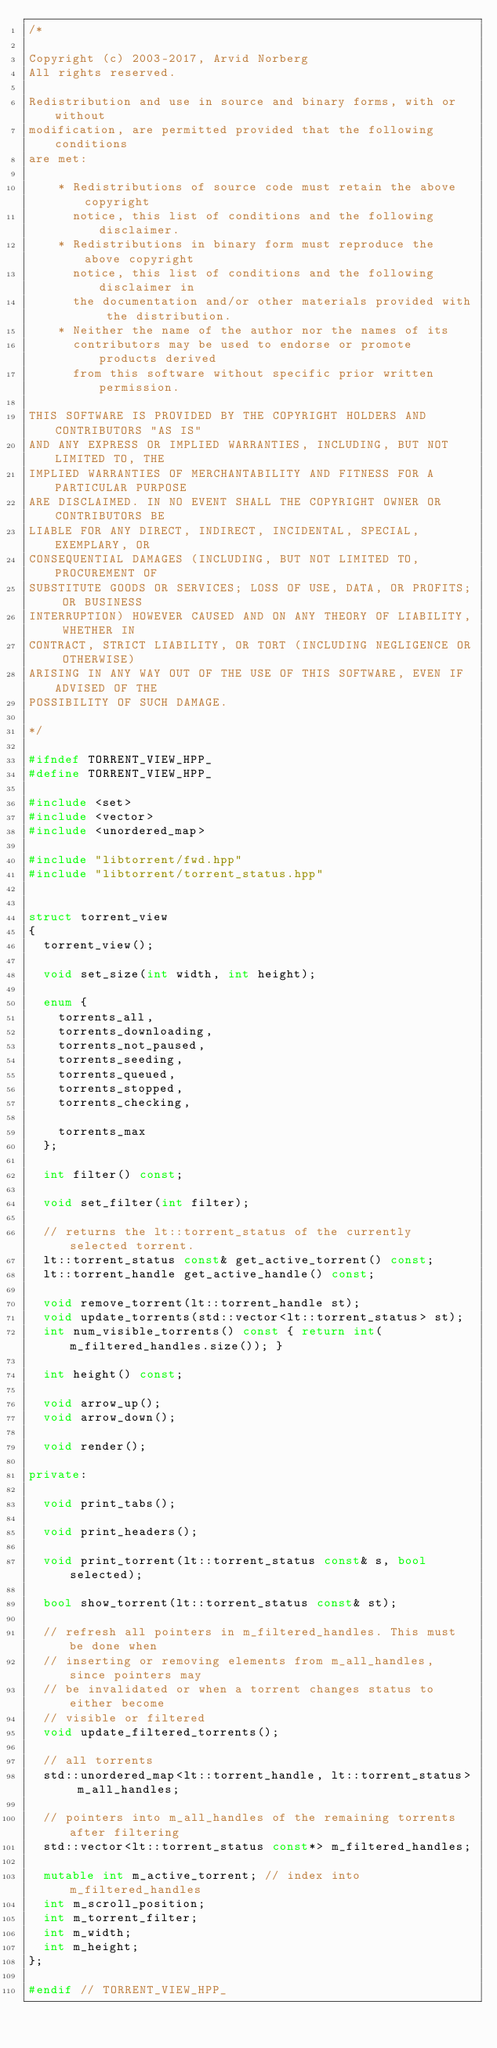<code> <loc_0><loc_0><loc_500><loc_500><_C++_>/*

Copyright (c) 2003-2017, Arvid Norberg
All rights reserved.

Redistribution and use in source and binary forms, with or without
modification, are permitted provided that the following conditions
are met:

    * Redistributions of source code must retain the above copyright
      notice, this list of conditions and the following disclaimer.
    * Redistributions in binary form must reproduce the above copyright
      notice, this list of conditions and the following disclaimer in
      the documentation and/or other materials provided with the distribution.
    * Neither the name of the author nor the names of its
      contributors may be used to endorse or promote products derived
      from this software without specific prior written permission.

THIS SOFTWARE IS PROVIDED BY THE COPYRIGHT HOLDERS AND CONTRIBUTORS "AS IS"
AND ANY EXPRESS OR IMPLIED WARRANTIES, INCLUDING, BUT NOT LIMITED TO, THE
IMPLIED WARRANTIES OF MERCHANTABILITY AND FITNESS FOR A PARTICULAR PURPOSE
ARE DISCLAIMED. IN NO EVENT SHALL THE COPYRIGHT OWNER OR CONTRIBUTORS BE
LIABLE FOR ANY DIRECT, INDIRECT, INCIDENTAL, SPECIAL, EXEMPLARY, OR
CONSEQUENTIAL DAMAGES (INCLUDING, BUT NOT LIMITED TO, PROCUREMENT OF
SUBSTITUTE GOODS OR SERVICES; LOSS OF USE, DATA, OR PROFITS; OR BUSINESS
INTERRUPTION) HOWEVER CAUSED AND ON ANY THEORY OF LIABILITY, WHETHER IN
CONTRACT, STRICT LIABILITY, OR TORT (INCLUDING NEGLIGENCE OR OTHERWISE)
ARISING IN ANY WAY OUT OF THE USE OF THIS SOFTWARE, EVEN IF ADVISED OF THE
POSSIBILITY OF SUCH DAMAGE.

*/

#ifndef TORRENT_VIEW_HPP_
#define TORRENT_VIEW_HPP_

#include <set>
#include <vector>
#include <unordered_map>

#include "libtorrent/fwd.hpp"
#include "libtorrent/torrent_status.hpp"


struct torrent_view
{
	torrent_view();

	void set_size(int width, int height);

	enum {
		torrents_all,
		torrents_downloading,
		torrents_not_paused,
		torrents_seeding,
		torrents_queued,
		torrents_stopped,
		torrents_checking,

		torrents_max
	};

	int filter() const;

	void set_filter(int filter);

	// returns the lt::torrent_status of the currently selected torrent.
	lt::torrent_status const& get_active_torrent() const;
	lt::torrent_handle get_active_handle() const;

	void remove_torrent(lt::torrent_handle st);
	void update_torrents(std::vector<lt::torrent_status> st);
	int num_visible_torrents() const { return int(m_filtered_handles.size()); }

	int height() const;

	void arrow_up();
	void arrow_down();

	void render();

private:

	void print_tabs();

	void print_headers();

	void print_torrent(lt::torrent_status const& s, bool selected);

	bool show_torrent(lt::torrent_status const& st);

	// refresh all pointers in m_filtered_handles. This must be done when
	// inserting or removing elements from m_all_handles, since pointers may
	// be invalidated or when a torrent changes status to either become
	// visible or filtered
	void update_filtered_torrents();

	// all torrents
	std::unordered_map<lt::torrent_handle, lt::torrent_status> m_all_handles;

	// pointers into m_all_handles of the remaining torrents after filtering
	std::vector<lt::torrent_status const*> m_filtered_handles;

	mutable int m_active_torrent; // index into m_filtered_handles
	int m_scroll_position;
	int m_torrent_filter;
	int m_width;
	int m_height;
};

#endif // TORRENT_VIEW_HPP_
</code> 